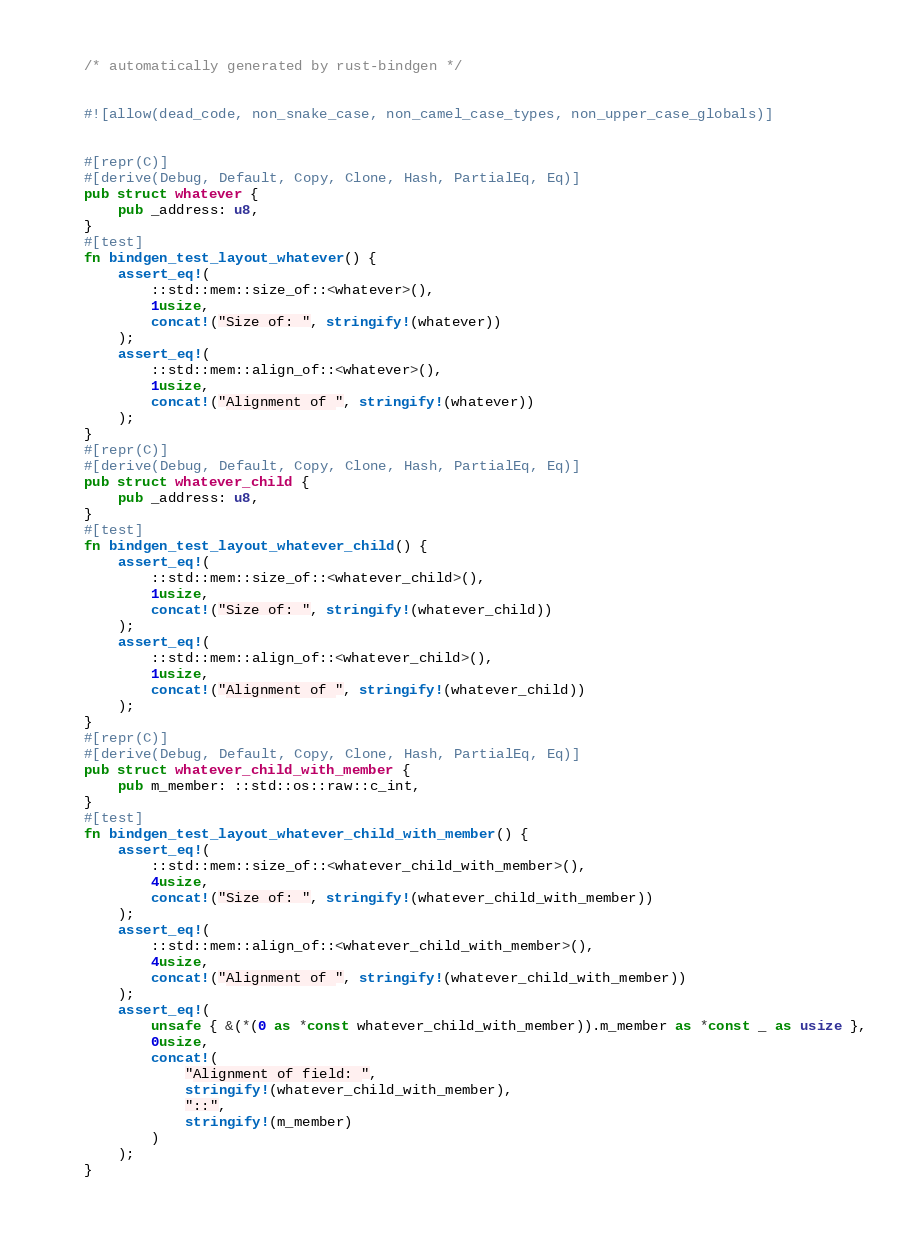Convert code to text. <code><loc_0><loc_0><loc_500><loc_500><_Rust_>/* automatically generated by rust-bindgen */


#![allow(dead_code, non_snake_case, non_camel_case_types, non_upper_case_globals)]


#[repr(C)]
#[derive(Debug, Default, Copy, Clone, Hash, PartialEq, Eq)]
pub struct whatever {
    pub _address: u8,
}
#[test]
fn bindgen_test_layout_whatever() {
    assert_eq!(
        ::std::mem::size_of::<whatever>(),
        1usize,
        concat!("Size of: ", stringify!(whatever))
    );
    assert_eq!(
        ::std::mem::align_of::<whatever>(),
        1usize,
        concat!("Alignment of ", stringify!(whatever))
    );
}
#[repr(C)]
#[derive(Debug, Default, Copy, Clone, Hash, PartialEq, Eq)]
pub struct whatever_child {
    pub _address: u8,
}
#[test]
fn bindgen_test_layout_whatever_child() {
    assert_eq!(
        ::std::mem::size_of::<whatever_child>(),
        1usize,
        concat!("Size of: ", stringify!(whatever_child))
    );
    assert_eq!(
        ::std::mem::align_of::<whatever_child>(),
        1usize,
        concat!("Alignment of ", stringify!(whatever_child))
    );
}
#[repr(C)]
#[derive(Debug, Default, Copy, Clone, Hash, PartialEq, Eq)]
pub struct whatever_child_with_member {
    pub m_member: ::std::os::raw::c_int,
}
#[test]
fn bindgen_test_layout_whatever_child_with_member() {
    assert_eq!(
        ::std::mem::size_of::<whatever_child_with_member>(),
        4usize,
        concat!("Size of: ", stringify!(whatever_child_with_member))
    );
    assert_eq!(
        ::std::mem::align_of::<whatever_child_with_member>(),
        4usize,
        concat!("Alignment of ", stringify!(whatever_child_with_member))
    );
    assert_eq!(
        unsafe { &(*(0 as *const whatever_child_with_member)).m_member as *const _ as usize },
        0usize,
        concat!(
            "Alignment of field: ",
            stringify!(whatever_child_with_member),
            "::",
            stringify!(m_member)
        )
    );
}
</code> 